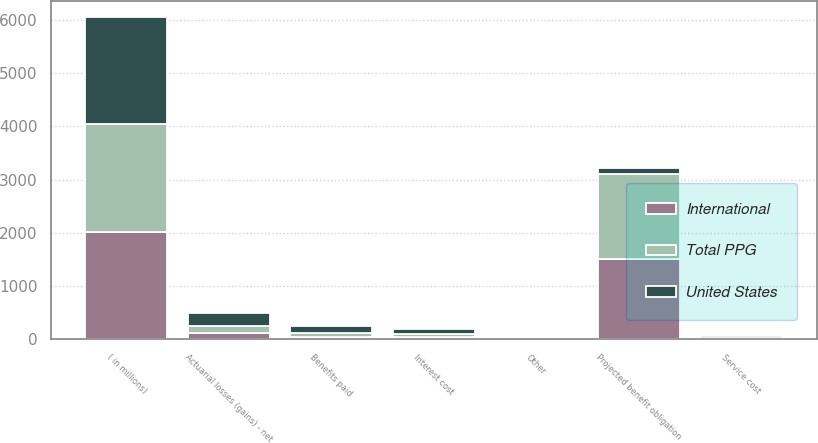<chart> <loc_0><loc_0><loc_500><loc_500><stacked_bar_chart><ecel><fcel>( in millions)<fcel>Projected benefit obligation<fcel>Service cost<fcel>Interest cost<fcel>Actuarial losses (gains) - net<fcel>Benefits paid<fcel>Other<nl><fcel>Total PPG<fcel>2018<fcel>1582<fcel>17<fcel>57<fcel>129<fcel>70<fcel>1<nl><fcel>International<fcel>2018<fcel>1518<fcel>11<fcel>40<fcel>117<fcel>55<fcel>3<nl><fcel>United States<fcel>2018<fcel>107<fcel>28<fcel>97<fcel>246<fcel>125<fcel>4<nl></chart> 